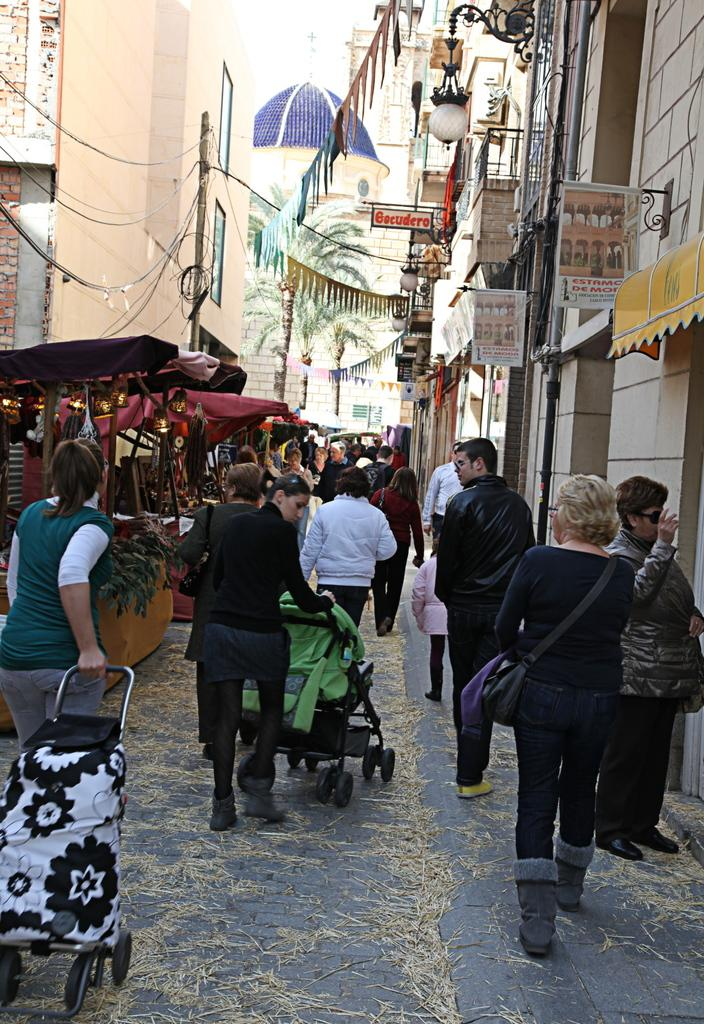What is happening on the street in the image? There are many people walking on the street in the image. What are the people wearing? The people are wearing clothes. What can be seen in the background of the image? There are buildings, an electric pole, electric wires, and a tree in the image. Can you describe the lighting in the image? There is a light in the image. What personal item is visible in the image? A handbag is visible in the image. How many snails are crawling on the handbag in the image? There are no snails visible in the image; only people, buildings, an electric pole, electric wires, a tree, a light, and a handbag can be seen. 